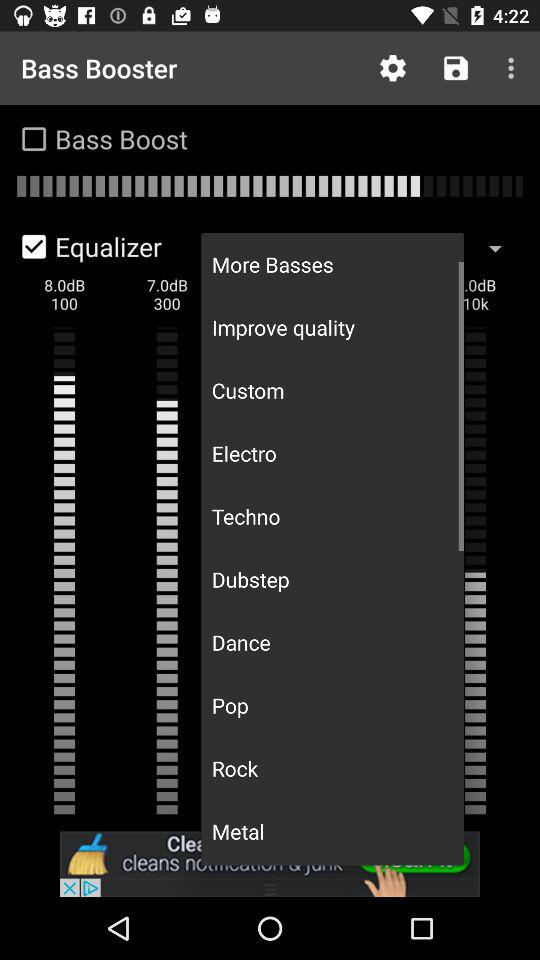How many more check boxes are there than text labels?
Answer the question using a single word or phrase. 1 